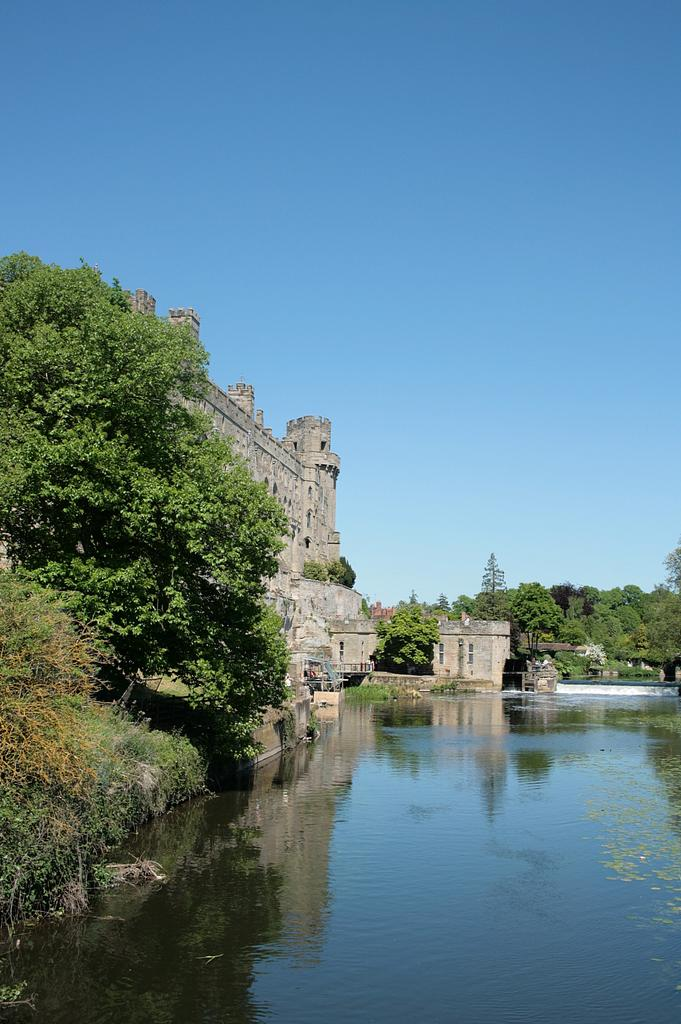What type of structure is present in the image? There is a building in the image. What other natural elements can be seen in the image? There are trees in the image. What is in front of the building? There is water in front of the building. What can be seen in the distance in the image? The sky is visible in the background of the image. What type of calculator can be seen on the queen's desk in the image? There is no calculator or queen present in the image; it features a building, trees, water, and the sky. 